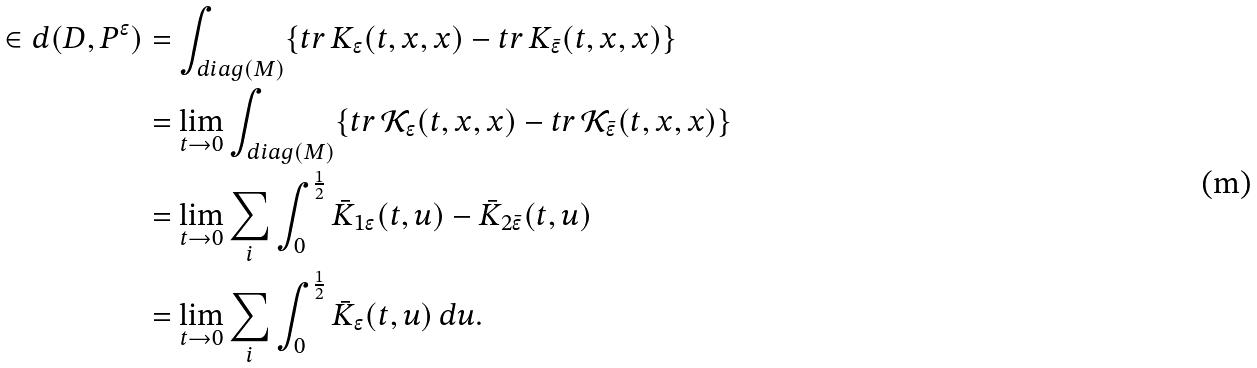Convert formula to latex. <formula><loc_0><loc_0><loc_500><loc_500>\in d ( D , P ^ { \epsilon } ) & = \int _ { d i a g ( M ) } \{ t r \, K _ { \epsilon } ( t , x , x ) - t r \, K _ { \bar { \epsilon } } ( t , x , x ) \} \\ & = \lim _ { t \to 0 } \int _ { d i a g ( M ) } \{ t r \, \mathcal { K } _ { \epsilon } ( t , x , x ) - t r \, \mathcal { K } _ { \bar { \epsilon } } ( t , x , x ) \} \\ & = \lim _ { t \to 0 } \sum _ { i } \int _ { 0 } ^ { \frac { 1 } { 2 } } \bar { K } _ { 1 \epsilon } ( t , u ) - \bar { K } _ { 2 \bar { \epsilon } } ( t , u ) \\ & = \lim _ { t \to 0 } \sum _ { i } \int _ { 0 } ^ { \frac { 1 } { 2 } } \bar { K } _ { \epsilon } ( t , u ) \, d u .</formula> 